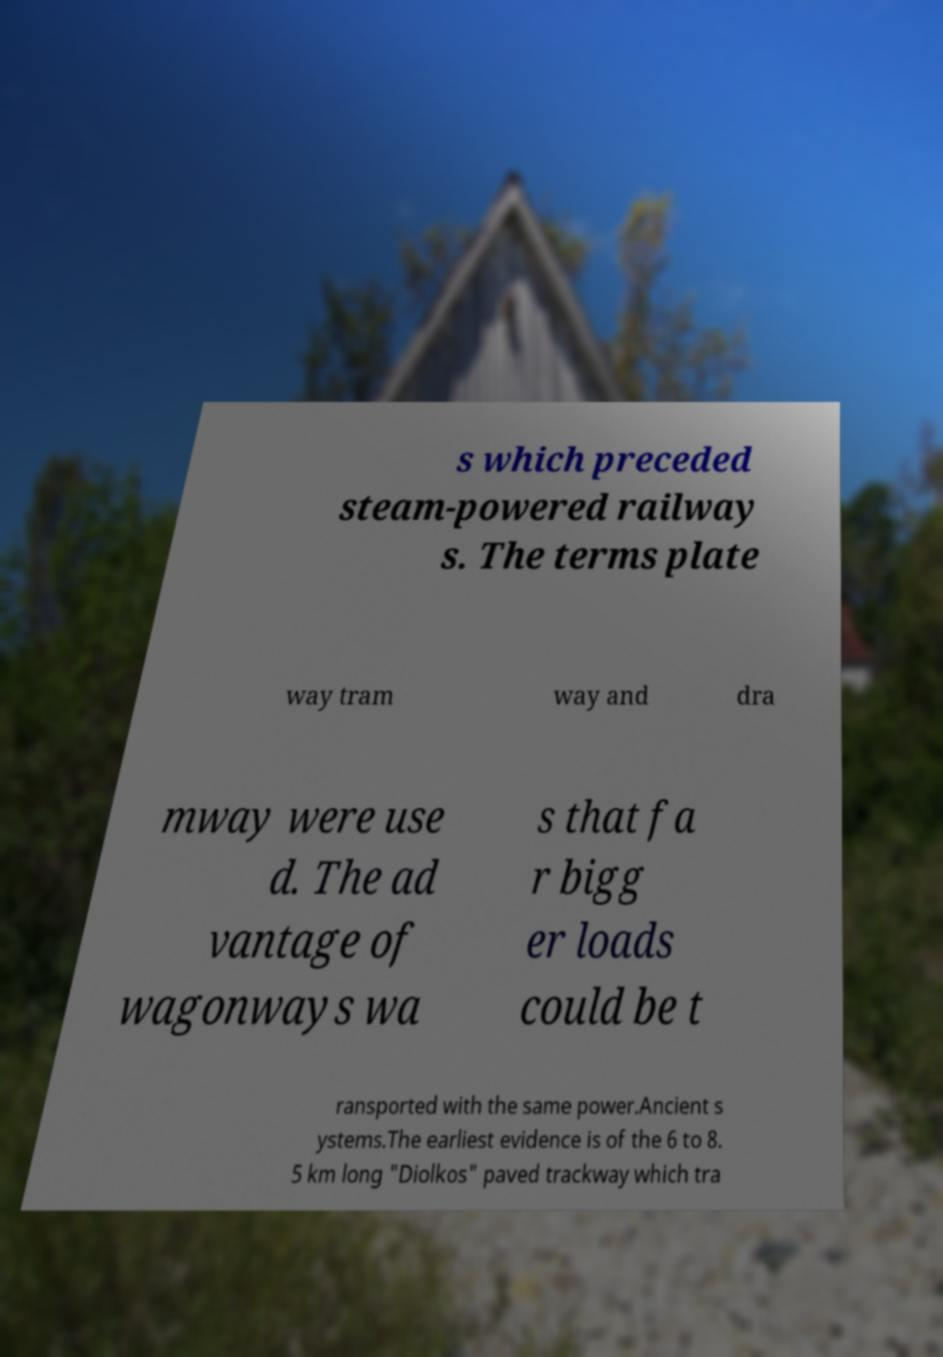Could you assist in decoding the text presented in this image and type it out clearly? s which preceded steam-powered railway s. The terms plate way tram way and dra mway were use d. The ad vantage of wagonways wa s that fa r bigg er loads could be t ransported with the same power.Ancient s ystems.The earliest evidence is of the 6 to 8. 5 km long "Diolkos" paved trackway which tra 